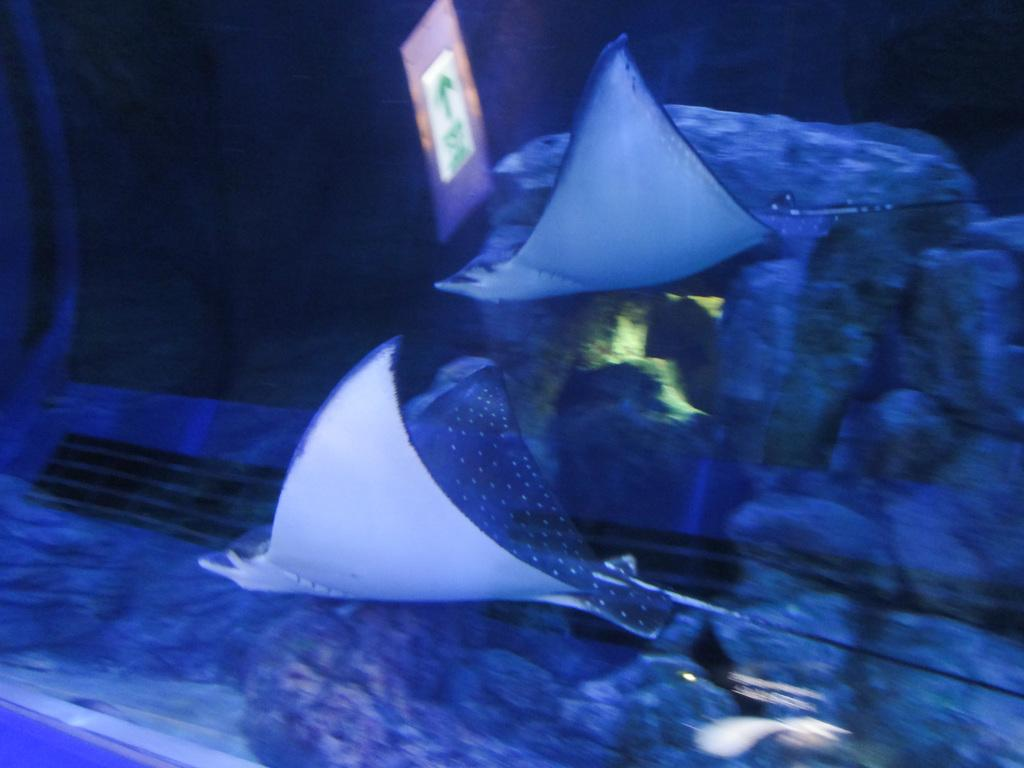What is the main feature of the image? There is a huge aquarium in the image. What is inside the aquarium? The aquarium contains water and aquatic animals. How can you describe the background of the image? The background of the image is dark. What type of stick can be seen holding up the list of answers in the image? There is no stick or list of answers present in the image. 